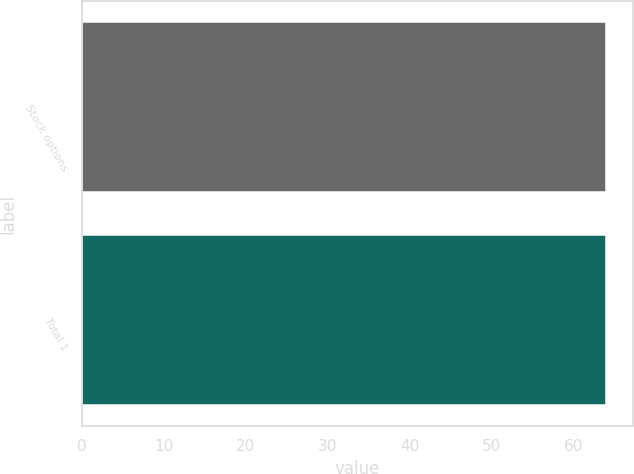<chart> <loc_0><loc_0><loc_500><loc_500><bar_chart><fcel>Stock options<fcel>Total 1<nl><fcel>63.93<fcel>64.03<nl></chart> 